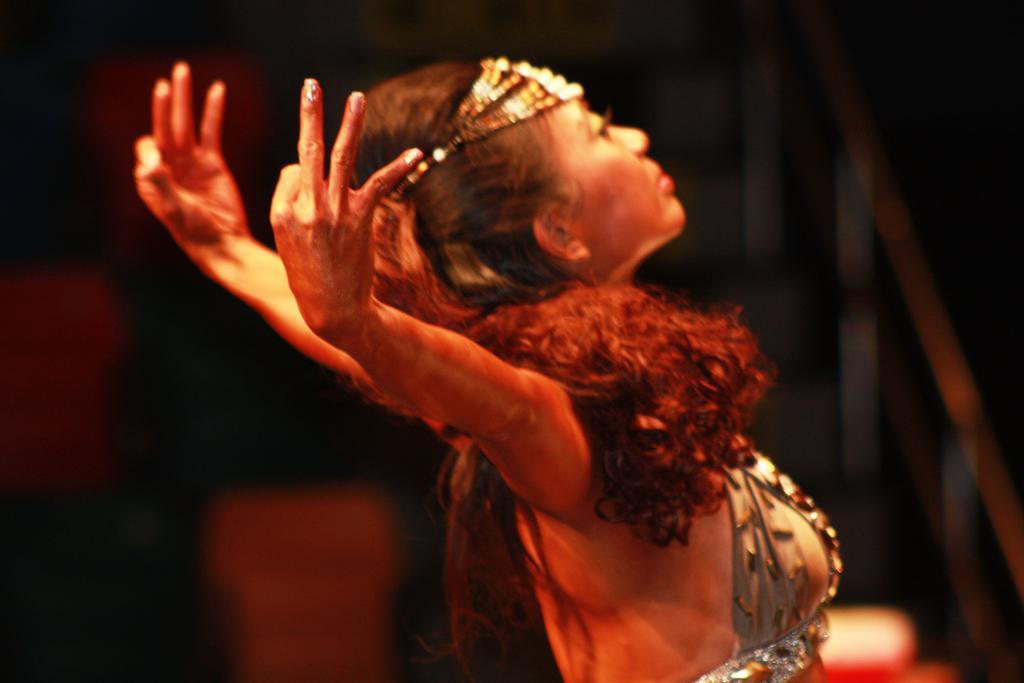In one or two sentences, can you explain what this image depicts? In the image we can see a woman wearing clothes and it looks like she is dancing and the background is blurred. 